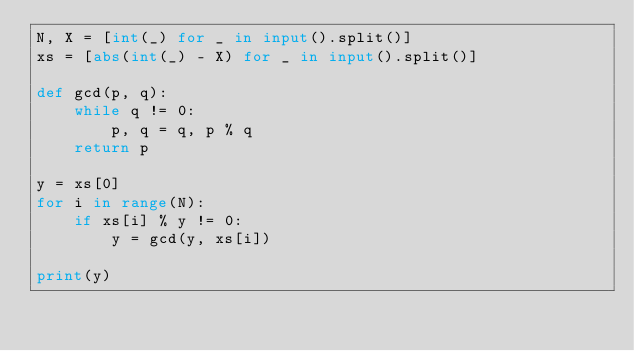Convert code to text. <code><loc_0><loc_0><loc_500><loc_500><_Python_>N, X = [int(_) for _ in input().split()]
xs = [abs(int(_) - X) for _ in input().split()]

def gcd(p, q):
    while q != 0:
        p, q = q, p % q
    return p

y = xs[0]
for i in range(N):
    if xs[i] % y != 0:
        y = gcd(y, xs[i])

print(y)</code> 